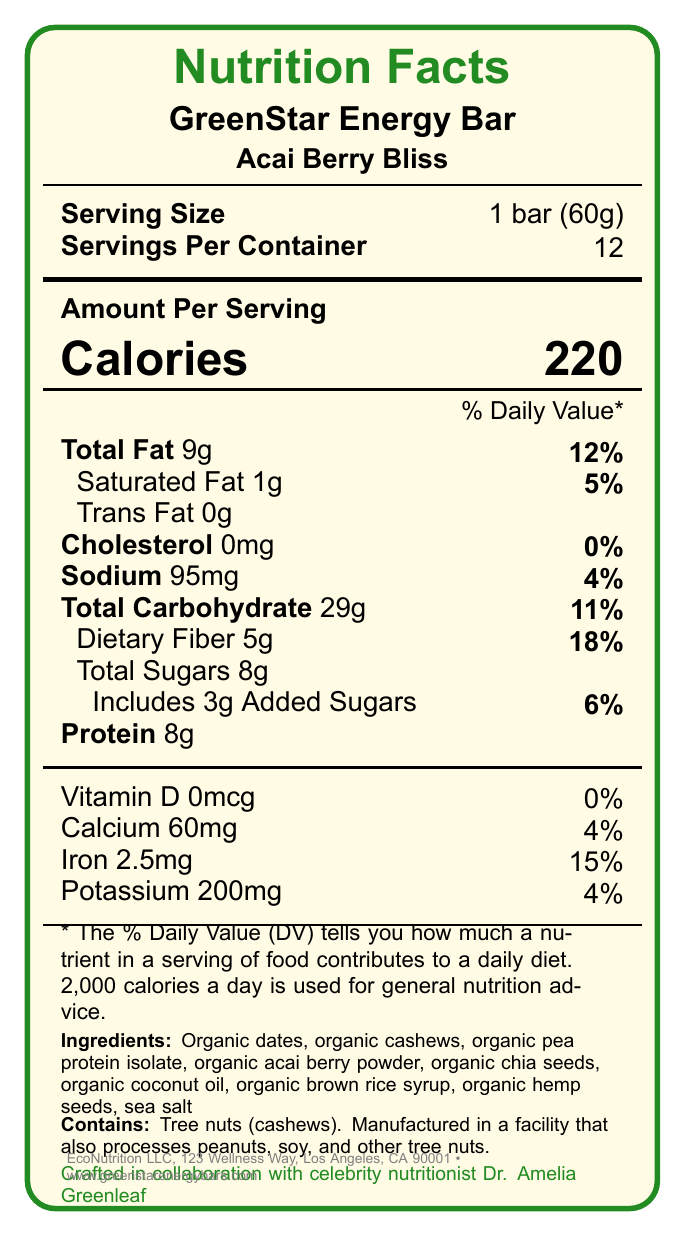What is the name of the product? The product name is mentioned at the top of the document under the section titled 'GreenStar Energy Bar'.
Answer: GreenStar Energy Bar What is the serving size for the GreenStar Energy Bar? The serving size is explicitly listed as "1 bar (60g)" below the product and flavor names.
Answer: 1 bar (60g) How many servings are in one container of the energy bars? The "Servings Per Container" section lists the number 12.
Answer: 12 What is the calorie content per serving of the GreenStar Energy Bar? The calorie content per serving is listed as "220" under the "Amount Per Serving" section.
Answer: 220 Which ingredient contributes tree nuts to the GreenStar Energy Bar? The ingredient list includes "Organic cashews," and the allergens section specifically mentions tree nuts (cashews).
Answer: Organic cashews What percentage of the daily value for dietary fiber does a single serving of the bar provide? The document states that the dietary fiber content per serving is 5g, which constitutes 18% of the daily value.
Answer: 18% What is the amount of sodium in one serving of the GreenStar Energy Bar? The sodium content is listed as "95mg" under the "Sodium" section.
Answer: 95mg Which of the following certifications does the GreenStar Energy Bar have? A. USDA Organic B. Non-GMO Project Verified C. Vegan D. All of the above The certifications section lists all three: USDA Organic, Non-GMO Project Verified, and Vegan.
Answer: D What is the amount of added sugars in the GreenStar Energy Bar? A. 3g B. 6g C. 8g D. 11g The document lists "Includes 3g Added Sugars" under the "total sugars" section.
Answer: A Does the bar contain any cholesterol? The document lists "Cholesterol 0mg,” indicating that the bar contains no cholesterol.
Answer: No Describe the main idea of the document. The document is structured to deliver detailed nutritional facts and promote the product's health benefits and sustainable practices, tailored for the eco-conscious and health-aware consumer.
Answer: The document provides nutritional information, ingredients, allergens, certifications, and sustainability statements for GreenStar Energy Bar in the flavor Acai Berry Bliss. It highlights the bar’s key nutrients, organic ingredients, sustainability credentials, and collaboration with celebrity nutritionist Dr. Amelia Greenleaf. Which company manufactures the GreenStar Energy Bar? The company information section at the bottom states EcoNutrition LLC as the manufacturer.
Answer: EcoNutrition LLC Is packaging for the GreenStar Energy Bar made from recycled materials? The sustainability statement mentions that the packaging is made from 100% recycled materials.
Answer: Yes What social media platforms feature GreenStar Energy Bar? The social media section lists Instagram (@greenstarenergy), Twitter (@greenstarenergy), and Facebook (GreenStarEnergyBars).
Answer: Instagram, Twitter, Facebook Who is the celebrity nutritionist involved in creating the GreenStar Energy Bar? The document specifically mentions that the bar is crafted in collaboration with celebrity nutritionist Dr. Amelia Greenleaf.
Answer: Dr. Amelia Greenleaf How much profit is donated to rainforest conservation efforts? The sustainability statement specifies that 1% of the profits are donated to rainforest conservation efforts.
Answer: 1% Can you find the fiber source ingredients in the GreenStar Energy Bar from the document? The document lists various organic ingredients, but it does not specify which ones contribute to the fiber content.
Answer: Not enough information 